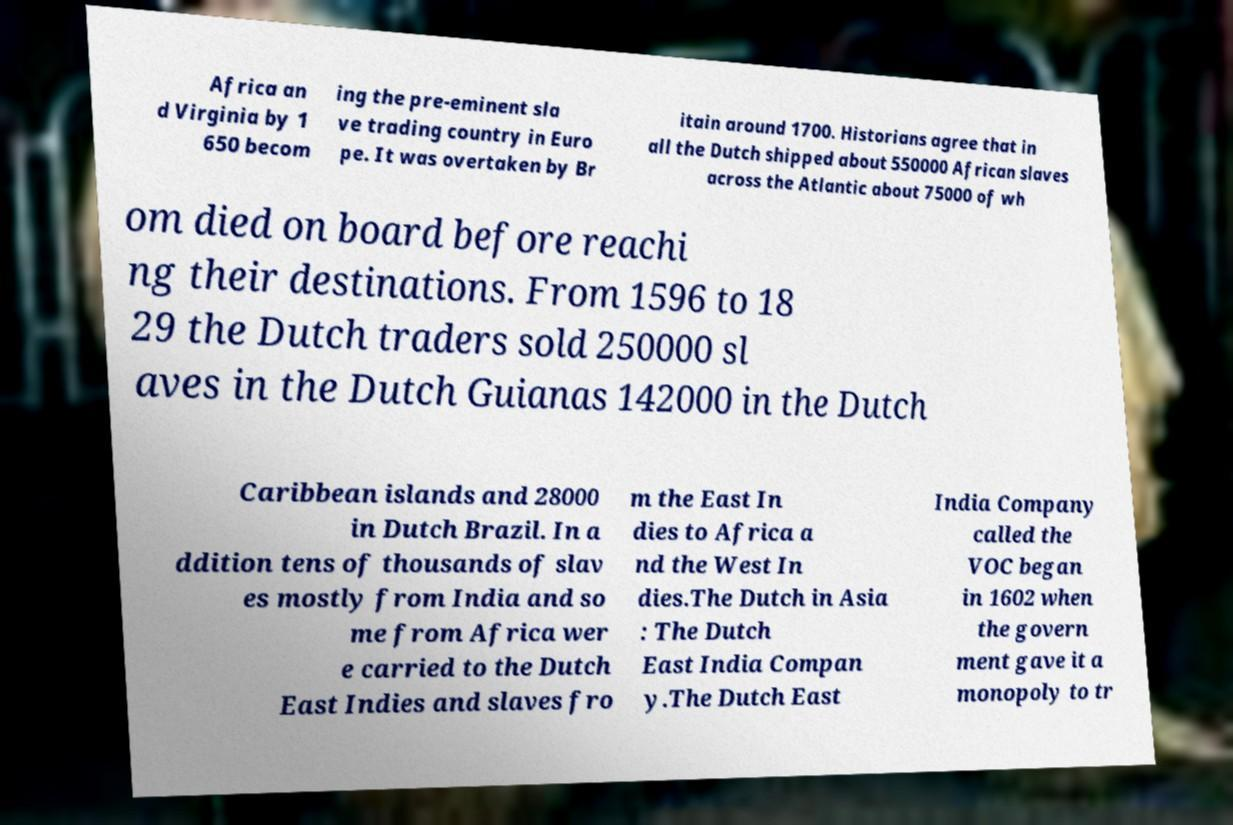Could you assist in decoding the text presented in this image and type it out clearly? Africa an d Virginia by 1 650 becom ing the pre-eminent sla ve trading country in Euro pe. It was overtaken by Br itain around 1700. Historians agree that in all the Dutch shipped about 550000 African slaves across the Atlantic about 75000 of wh om died on board before reachi ng their destinations. From 1596 to 18 29 the Dutch traders sold 250000 sl aves in the Dutch Guianas 142000 in the Dutch Caribbean islands and 28000 in Dutch Brazil. In a ddition tens of thousands of slav es mostly from India and so me from Africa wer e carried to the Dutch East Indies and slaves fro m the East In dies to Africa a nd the West In dies.The Dutch in Asia : The Dutch East India Compan y.The Dutch East India Company called the VOC began in 1602 when the govern ment gave it a monopoly to tr 